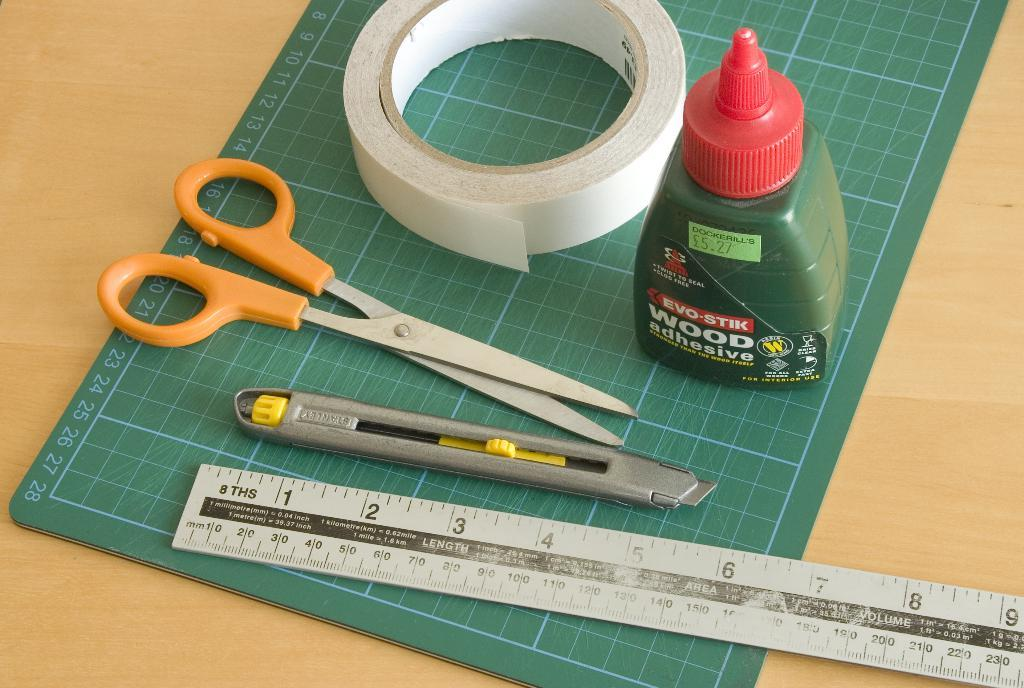<image>
Offer a succinct explanation of the picture presented. measuring tools and implements including EVO-STICK Wood Adhesive 